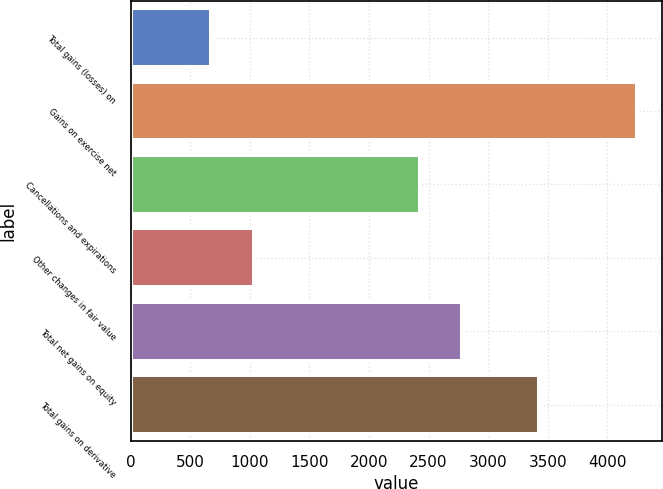Convert chart to OTSL. <chart><loc_0><loc_0><loc_500><loc_500><bar_chart><fcel>Total gains (losses) on<fcel>Gains on exercise net<fcel>Cancellations and expirations<fcel>Other changes in fair value<fcel>Total net gains on equity<fcel>Total gains on derivative<nl><fcel>679<fcel>4245<fcel>2424<fcel>1035.6<fcel>2780.6<fcel>3428<nl></chart> 